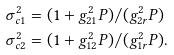<formula> <loc_0><loc_0><loc_500><loc_500>\sigma _ { c 1 } ^ { 2 } & = ( 1 + g _ { 2 1 } ^ { 2 } P ) / ( g _ { 2 r } ^ { 2 } P ) \\ \sigma _ { c 2 } ^ { 2 } & = ( 1 + g _ { 1 2 } ^ { 2 } P ) / ( g _ { 1 r } ^ { 2 } P ) .</formula> 